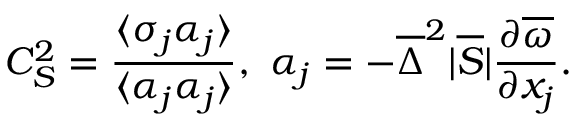Convert formula to latex. <formula><loc_0><loc_0><loc_500><loc_500>C _ { S } ^ { 2 } = \frac { \langle \sigma _ { j } \alpha _ { j } \rangle } { \langle \alpha _ { j } \alpha _ { j } \rangle } , \alpha _ { j } = - \overline { \Delta } ^ { 2 } | \overline { S } | \frac { \partial \overline { \omega } } { \partial x _ { j } } .</formula> 